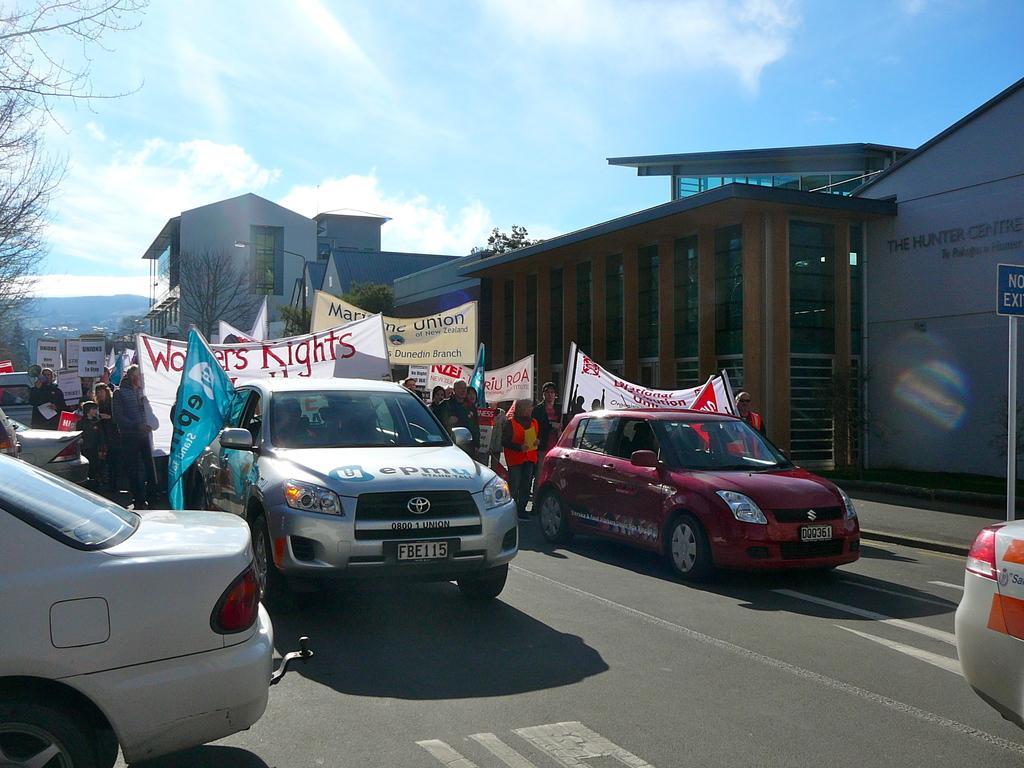How would you summarize this image in a sentence or two? In this image I can see road and on it I can see white lines, few cars and number of people. I can also see number of banners and on these banners I can see something is written. I can also see buildings, trees, sky, clouds and here I can see a blue color sign board. 